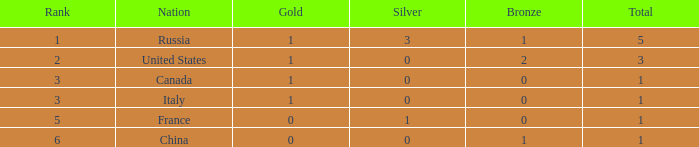Name the total number of ranks when total is less than 1 0.0. 